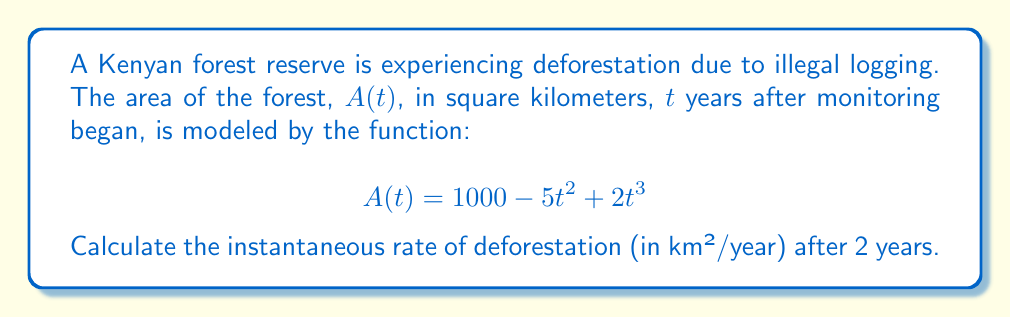Give your solution to this math problem. To find the instantaneous rate of deforestation after 2 years, we need to follow these steps:

1) The rate of change in the forest area is given by the derivative of $A(t)$ with respect to $t$.

2) Let's find $\frac{dA}{dt}$ using the power rule:

   $$\frac{dA}{dt} = 0 - 10t + 6t^2$$

3) Simplify:

   $$\frac{dA}{dt} = 6t^2 - 10t$$

4) The rate of deforestation is the negative of this value (since deforestation decreases the area):

   Rate of deforestation = $-(6t^2 - 10t)$ = $10t - 6t^2$

5) To find the rate after 2 years, substitute $t = 2$:

   Rate at $t = 2$ = $10(2) - 6(2)^2$
                   = $20 - 6(4)$
                   = $20 - 24$
                   = $-4$

The negative sign indicates that the forest area is decreasing.
Answer: 4 km²/year 